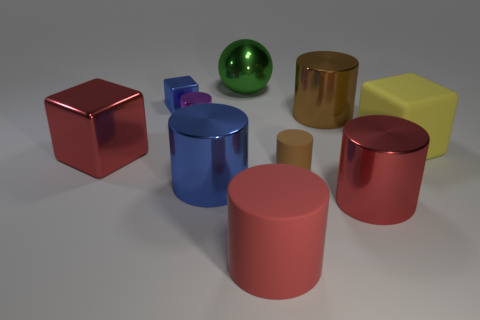What number of things are either small objects that are in front of the yellow matte block or tiny red metal cubes?
Keep it short and to the point. 1. There is another small thing that is the same shape as the tiny matte thing; what is its color?
Make the answer very short. Purple. Is there anything else that has the same color as the small metallic cylinder?
Give a very brief answer. No. There is a blue object in front of the brown rubber object; how big is it?
Ensure brevity in your answer.  Large. Is the color of the tiny cube the same as the big shiny cylinder that is left of the large green sphere?
Your response must be concise. Yes. How many other objects are the same material as the tiny blue cube?
Your response must be concise. 6. Are there more large red blocks than small red matte things?
Make the answer very short. Yes. Is the color of the large cube on the left side of the rubber cube the same as the big matte cylinder?
Your answer should be compact. Yes. The small block has what color?
Your response must be concise. Blue. There is a big shiny cylinder behind the brown rubber object; is there a brown rubber cylinder that is behind it?
Give a very brief answer. No. 